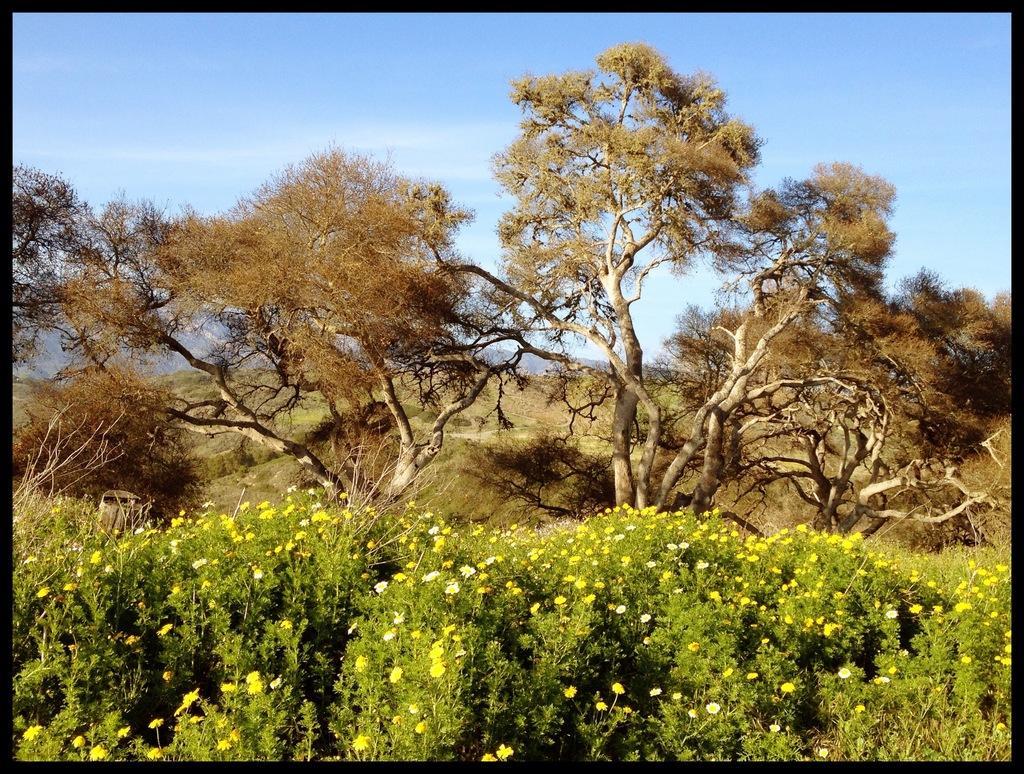Could you give a brief overview of what you see in this image? In this picture I can see trees, few plants with flowers and a blue cloudy sky. 